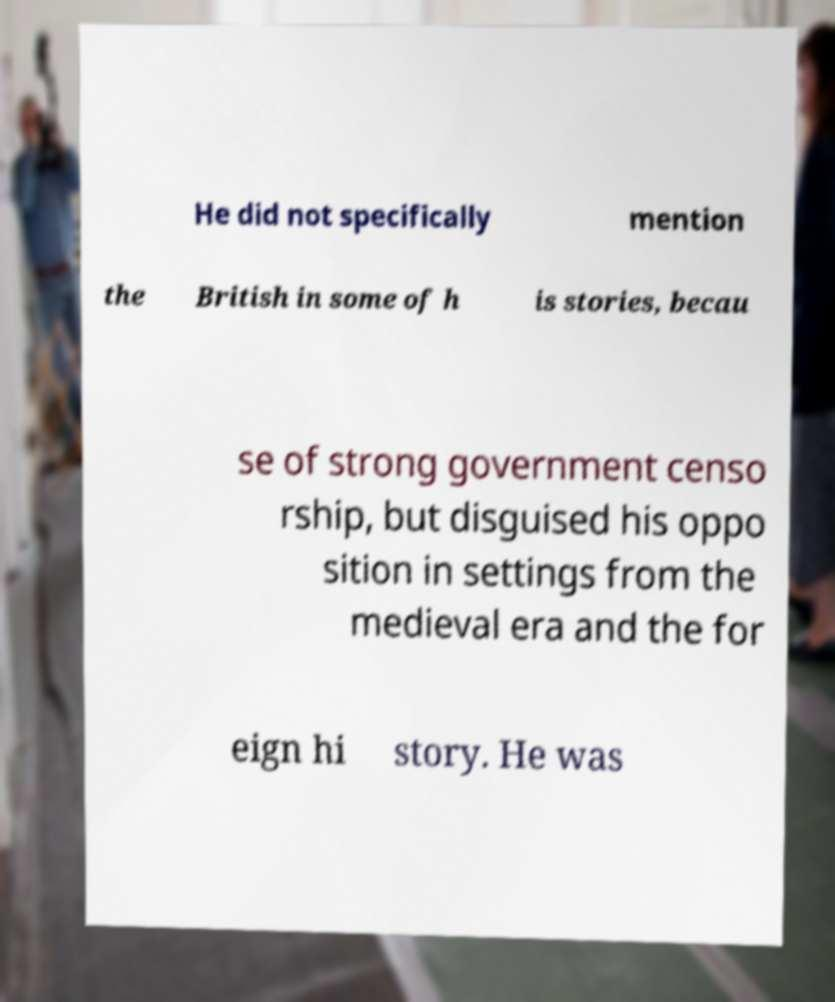For documentation purposes, I need the text within this image transcribed. Could you provide that? He did not specifically mention the British in some of h is stories, becau se of strong government censo rship, but disguised his oppo sition in settings from the medieval era and the for eign hi story. He was 